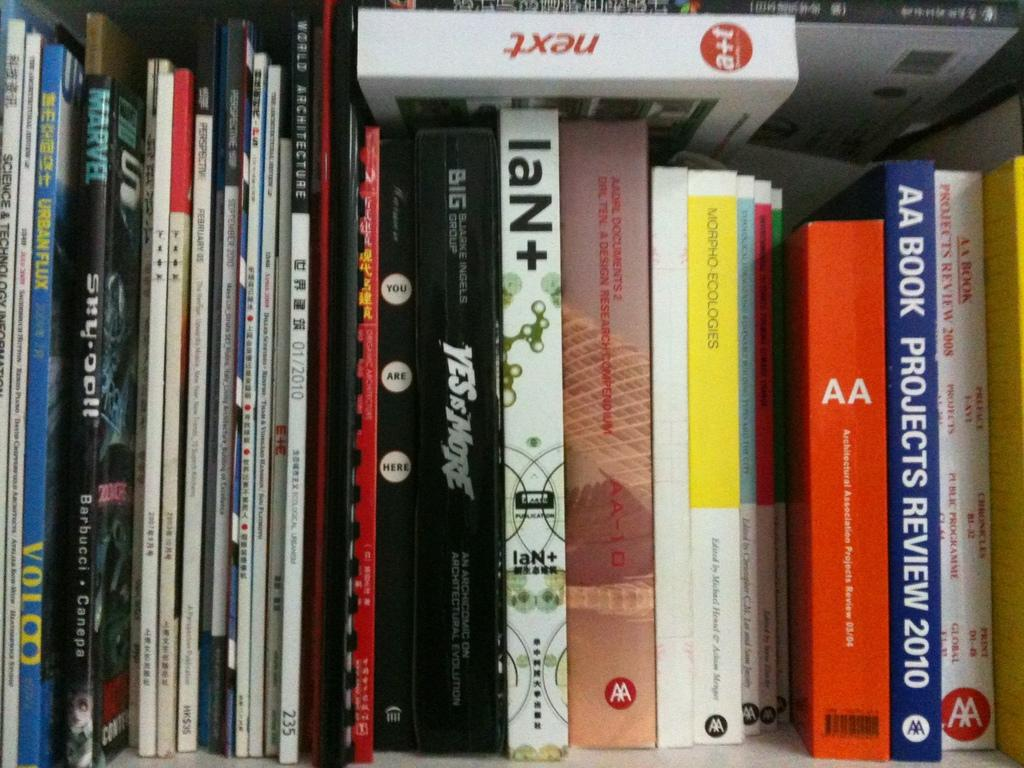<image>
Give a short and clear explanation of the subsequent image. A book collection including Projects Review 2010 among others. 